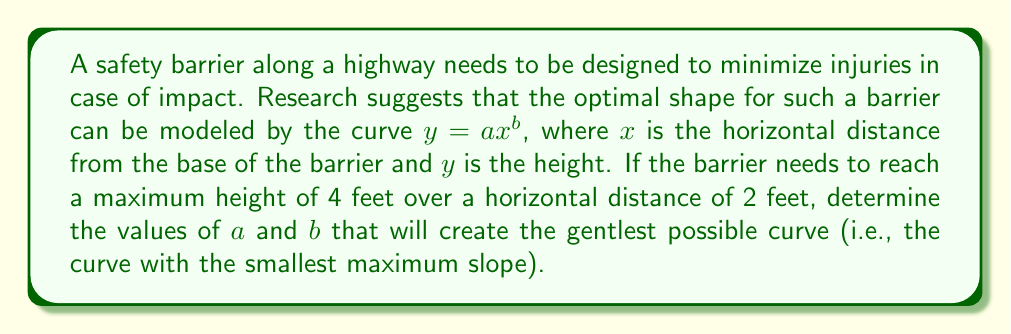Can you answer this question? Let's approach this step-by-step:

1) We know that the curve passes through the point (2, 4), so we can write:
   
   $4 = a(2)^b$

2) To find the slope of the curve, we need to differentiate $y = ax^b$:
   
   $\frac{dy}{dx} = abx^{b-1}$

3) The maximum slope will occur at $x = 2$ (the endpoint of our barrier). So we want to minimize:
   
   $\frac{dy}{dx}|_{x=2} = ab(2)^{b-1}$

4) From step 1, we can express $a$ in terms of $b$:
   
   $a = \frac{4}{2^b} = 2^{2-b}$

5) Substituting this into our slope expression:
   
   $\frac{dy}{dx}|_{x=2} = 2^{2-b} \cdot b \cdot 2^{b-1} = b \cdot 2$

6) To minimize this, we simply need to minimize $b$. However, $b$ cannot be negative or zero, as this would result in an invalid or undefined curve.

7) Therefore, the smallest possible positive value for $b$ is the one that will give us the gentlest curve. In practice, this would be a very small positive number, approaching but not reaching zero.

8) As $b$ approaches 0, $a$ approaches 4 (from step 4).

Therefore, the optimal values are:
$b$ approaching 0 (but remaining positive)
$a$ approaching 4
Answer: $a \approx 4$, $b \approx 0^+$ (positive number very close to zero) 